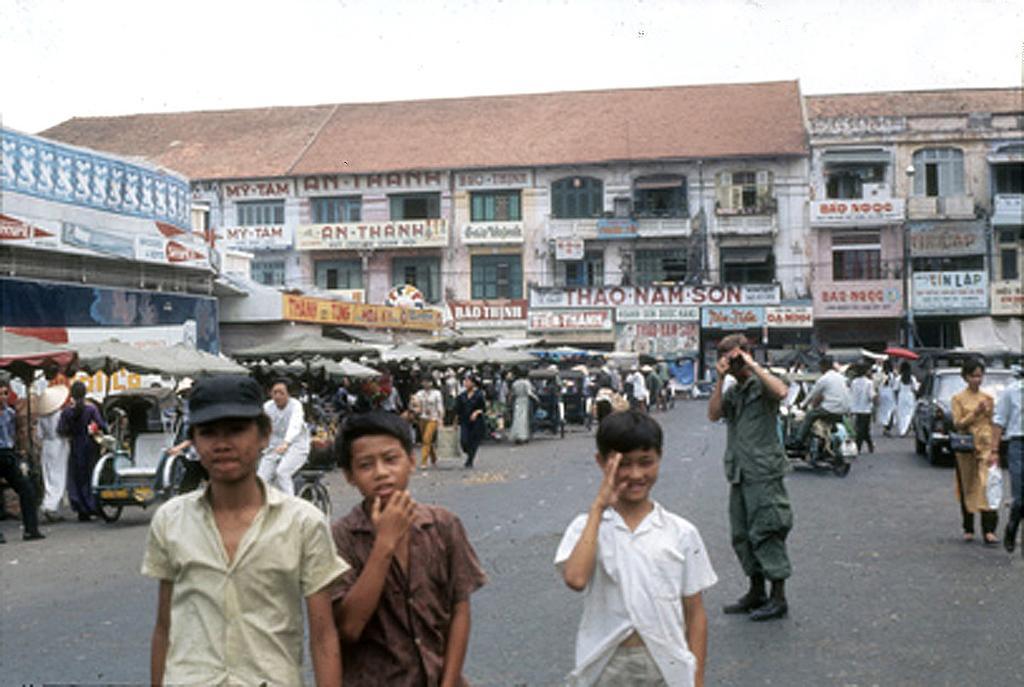Describe this image in one or two sentences. This is the picture of a road. In this image there are group people, few are walking and few are standing on the road. There is a person with green shirt is standing and holding the object. There is a person riding motor bike and there are vehicles on the road and there are tents on the road. At the back there are buildings and there are hoardings on the buildings. At the top there is sky. At the bottom there is a road. 